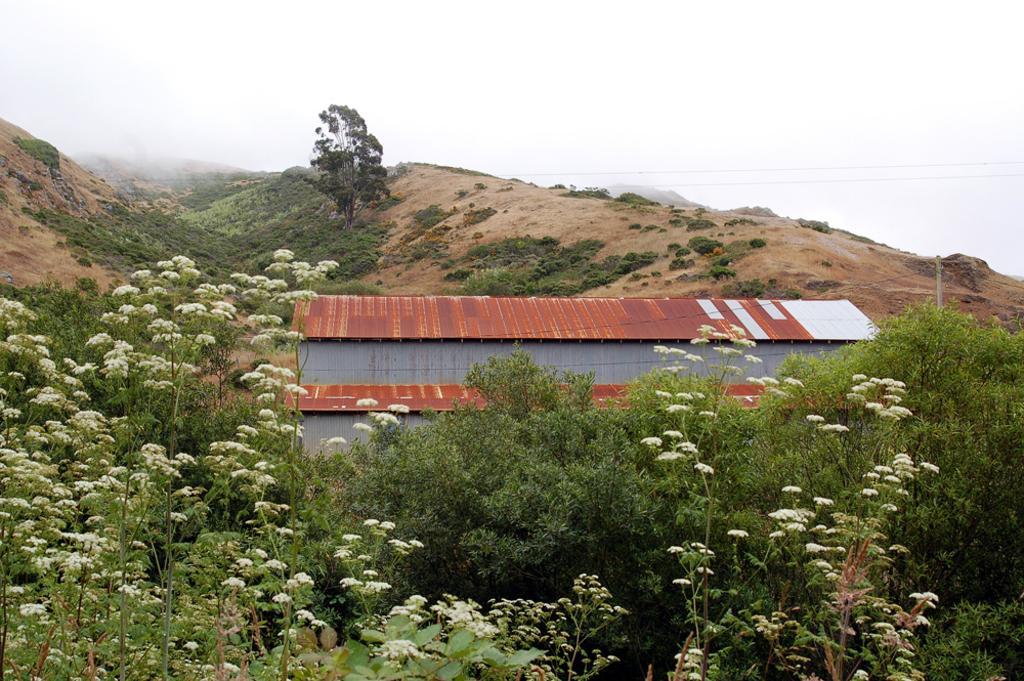Please provide a concise description of this image. This picture is clicked outside. In the foreground we can see the trees and flowers. In the center there is a house. In the background we can see the sky, grass and hills and some plants. 